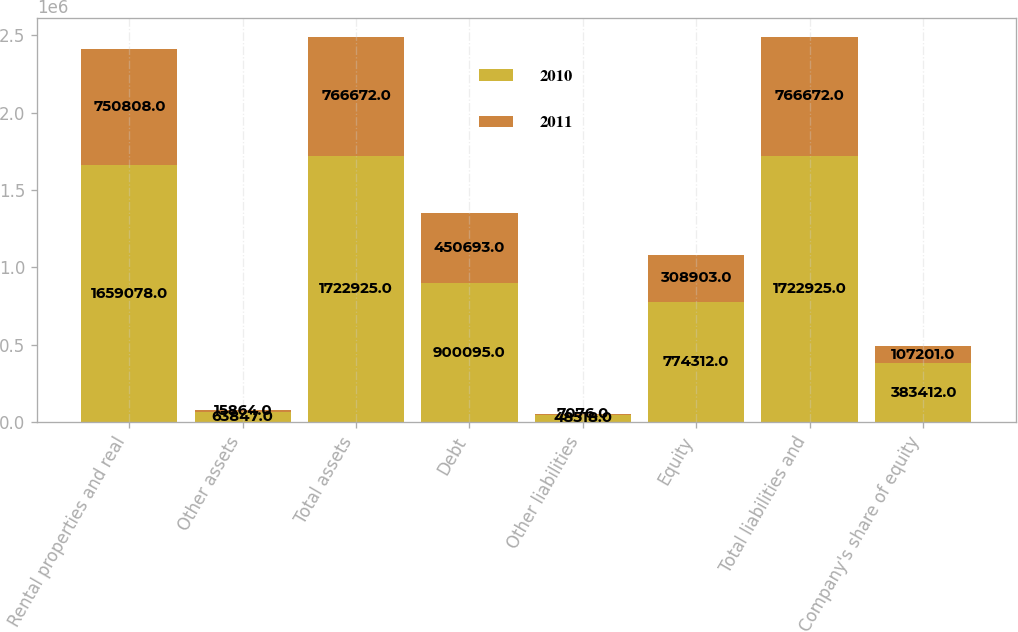<chart> <loc_0><loc_0><loc_500><loc_500><stacked_bar_chart><ecel><fcel>Rental properties and real<fcel>Other assets<fcel>Total assets<fcel>Debt<fcel>Other liabilities<fcel>Equity<fcel>Total liabilities and<fcel>Company's share of equity<nl><fcel>2010<fcel>1.65908e+06<fcel>63847<fcel>1.72292e+06<fcel>900095<fcel>48518<fcel>774312<fcel>1.72292e+06<fcel>383412<nl><fcel>2011<fcel>750808<fcel>15864<fcel>766672<fcel>450693<fcel>7076<fcel>308903<fcel>766672<fcel>107201<nl></chart> 